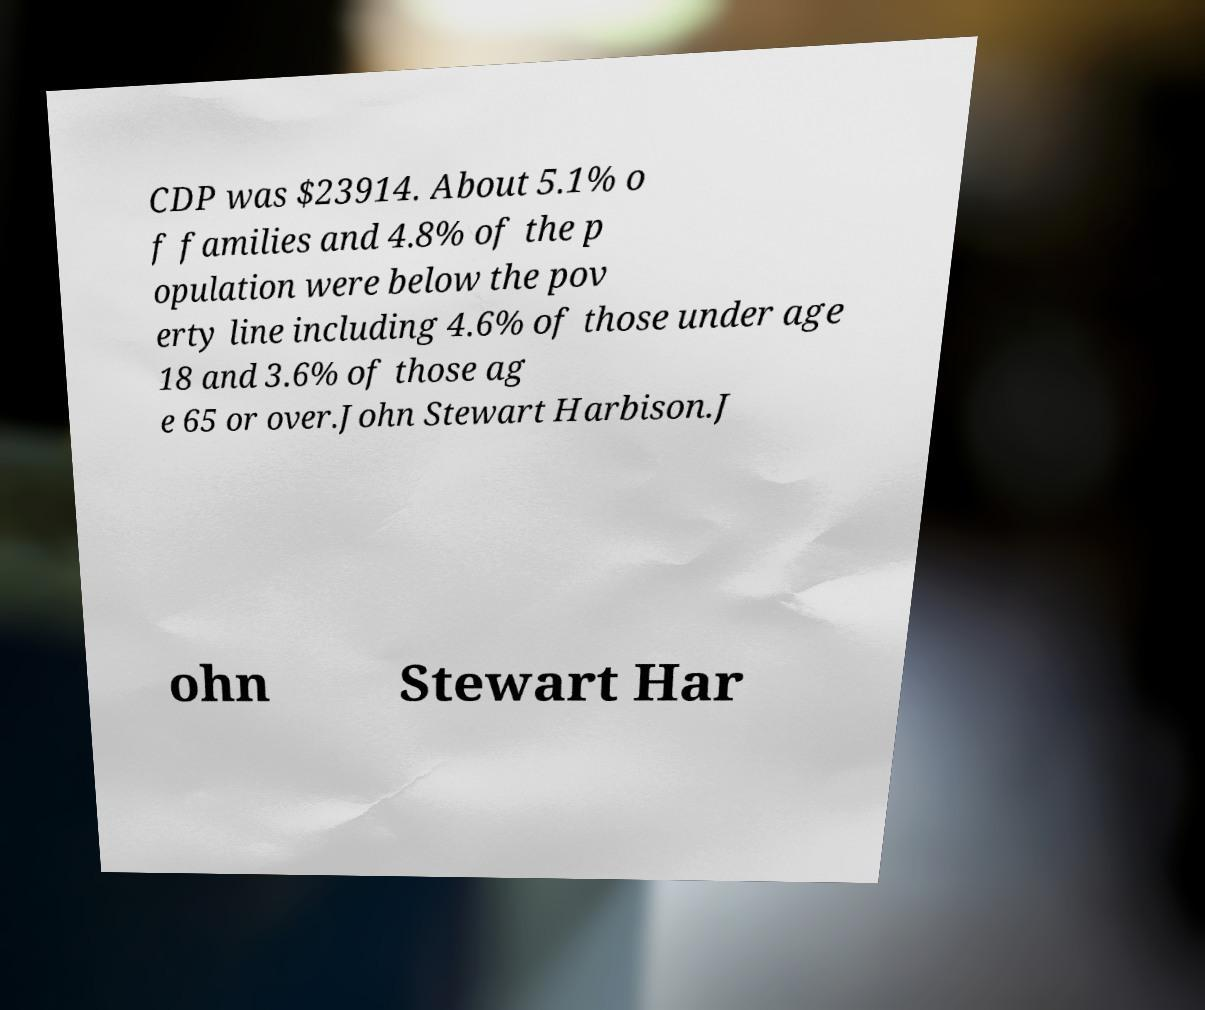Could you extract and type out the text from this image? CDP was $23914. About 5.1% o f families and 4.8% of the p opulation were below the pov erty line including 4.6% of those under age 18 and 3.6% of those ag e 65 or over.John Stewart Harbison.J ohn Stewart Har 